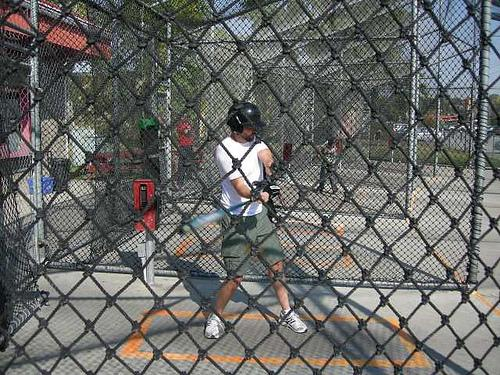What is the man standing in? batting cage 